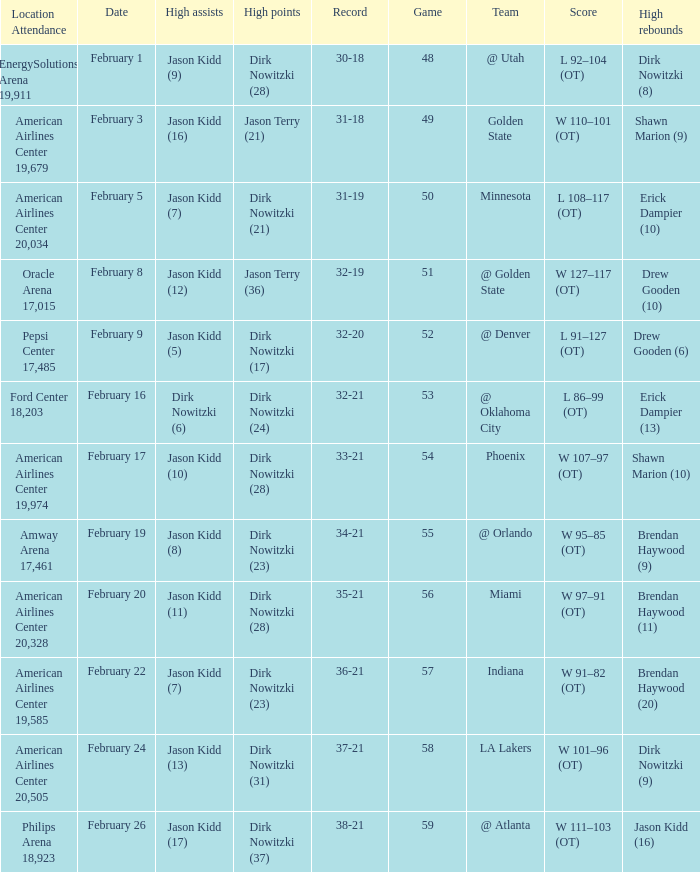Who had the most high assists with a record of 32-19? Jason Kidd (12). 